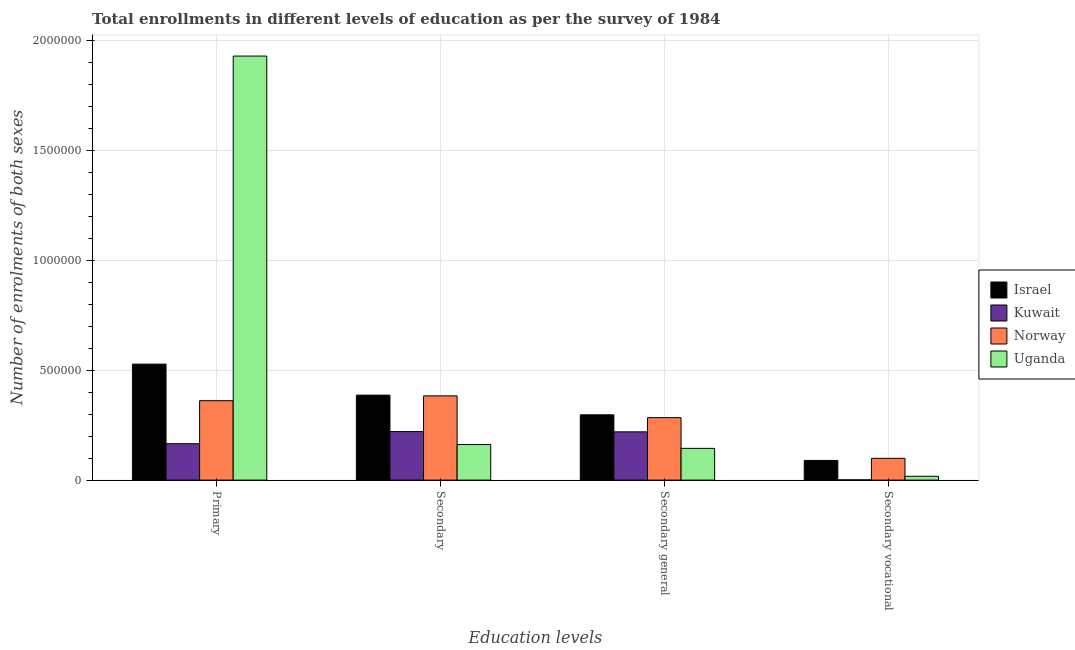How many groups of bars are there?
Provide a succinct answer. 4. Are the number of bars per tick equal to the number of legend labels?
Your answer should be compact. Yes. Are the number of bars on each tick of the X-axis equal?
Provide a succinct answer. Yes. How many bars are there on the 1st tick from the left?
Make the answer very short. 4. How many bars are there on the 1st tick from the right?
Ensure brevity in your answer.  4. What is the label of the 2nd group of bars from the left?
Provide a short and direct response. Secondary. What is the number of enrolments in secondary education in Israel?
Offer a very short reply. 3.87e+05. Across all countries, what is the maximum number of enrolments in secondary education?
Keep it short and to the point. 3.87e+05. Across all countries, what is the minimum number of enrolments in secondary general education?
Your answer should be compact. 1.45e+05. In which country was the number of enrolments in primary education maximum?
Provide a short and direct response. Uganda. In which country was the number of enrolments in primary education minimum?
Make the answer very short. Kuwait. What is the total number of enrolments in secondary general education in the graph?
Your response must be concise. 9.46e+05. What is the difference between the number of enrolments in secondary vocational education in Norway and that in Uganda?
Your response must be concise. 8.17e+04. What is the difference between the number of enrolments in secondary education in Uganda and the number of enrolments in secondary general education in Norway?
Provide a short and direct response. -1.22e+05. What is the average number of enrolments in secondary general education per country?
Your answer should be compact. 2.36e+05. What is the difference between the number of enrolments in secondary general education and number of enrolments in secondary education in Norway?
Your response must be concise. -9.91e+04. What is the ratio of the number of enrolments in secondary general education in Norway to that in Israel?
Your response must be concise. 0.96. Is the difference between the number of enrolments in secondary general education in Kuwait and Israel greater than the difference between the number of enrolments in secondary vocational education in Kuwait and Israel?
Your response must be concise. Yes. What is the difference between the highest and the second highest number of enrolments in secondary vocational education?
Offer a very short reply. 9485. What is the difference between the highest and the lowest number of enrolments in secondary vocational education?
Provide a succinct answer. 9.79e+04. In how many countries, is the number of enrolments in primary education greater than the average number of enrolments in primary education taken over all countries?
Your answer should be very brief. 1. What does the 3rd bar from the right in Secondary general represents?
Keep it short and to the point. Kuwait. How many bars are there?
Provide a succinct answer. 16. Are all the bars in the graph horizontal?
Give a very brief answer. No. What is the difference between two consecutive major ticks on the Y-axis?
Provide a succinct answer. 5.00e+05. Are the values on the major ticks of Y-axis written in scientific E-notation?
Provide a short and direct response. No. Does the graph contain any zero values?
Make the answer very short. No. Does the graph contain grids?
Ensure brevity in your answer.  Yes. Where does the legend appear in the graph?
Offer a very short reply. Center right. How many legend labels are there?
Make the answer very short. 4. What is the title of the graph?
Make the answer very short. Total enrollments in different levels of education as per the survey of 1984. Does "United Kingdom" appear as one of the legend labels in the graph?
Your response must be concise. No. What is the label or title of the X-axis?
Ensure brevity in your answer.  Education levels. What is the label or title of the Y-axis?
Provide a succinct answer. Number of enrolments of both sexes. What is the Number of enrolments of both sexes in Israel in Primary?
Your answer should be very brief. 5.28e+05. What is the Number of enrolments of both sexes of Kuwait in Primary?
Provide a succinct answer. 1.66e+05. What is the Number of enrolments of both sexes in Norway in Primary?
Your answer should be compact. 3.62e+05. What is the Number of enrolments of both sexes in Uganda in Primary?
Your answer should be compact. 1.93e+06. What is the Number of enrolments of both sexes in Israel in Secondary?
Your answer should be compact. 3.87e+05. What is the Number of enrolments of both sexes in Kuwait in Secondary?
Offer a very short reply. 2.21e+05. What is the Number of enrolments of both sexes in Norway in Secondary?
Your answer should be compact. 3.83e+05. What is the Number of enrolments of both sexes in Uganda in Secondary?
Your answer should be compact. 1.62e+05. What is the Number of enrolments of both sexes in Israel in Secondary general?
Your response must be concise. 2.97e+05. What is the Number of enrolments of both sexes of Kuwait in Secondary general?
Keep it short and to the point. 2.20e+05. What is the Number of enrolments of both sexes in Norway in Secondary general?
Offer a terse response. 2.84e+05. What is the Number of enrolments of both sexes of Uganda in Secondary general?
Keep it short and to the point. 1.45e+05. What is the Number of enrolments of both sexes of Israel in Secondary vocational?
Your response must be concise. 8.96e+04. What is the Number of enrolments of both sexes in Kuwait in Secondary vocational?
Give a very brief answer. 1223. What is the Number of enrolments of both sexes in Norway in Secondary vocational?
Make the answer very short. 9.91e+04. What is the Number of enrolments of both sexes in Uganda in Secondary vocational?
Ensure brevity in your answer.  1.75e+04. Across all Education levels, what is the maximum Number of enrolments of both sexes in Israel?
Your answer should be compact. 5.28e+05. Across all Education levels, what is the maximum Number of enrolments of both sexes in Kuwait?
Offer a very short reply. 2.21e+05. Across all Education levels, what is the maximum Number of enrolments of both sexes in Norway?
Offer a terse response. 3.83e+05. Across all Education levels, what is the maximum Number of enrolments of both sexes of Uganda?
Offer a very short reply. 1.93e+06. Across all Education levels, what is the minimum Number of enrolments of both sexes of Israel?
Make the answer very short. 8.96e+04. Across all Education levels, what is the minimum Number of enrolments of both sexes in Kuwait?
Provide a succinct answer. 1223. Across all Education levels, what is the minimum Number of enrolments of both sexes of Norway?
Your answer should be compact. 9.91e+04. Across all Education levels, what is the minimum Number of enrolments of both sexes in Uganda?
Offer a terse response. 1.75e+04. What is the total Number of enrolments of both sexes of Israel in the graph?
Offer a very short reply. 1.30e+06. What is the total Number of enrolments of both sexes in Kuwait in the graph?
Provide a short and direct response. 6.08e+05. What is the total Number of enrolments of both sexes of Norway in the graph?
Ensure brevity in your answer.  1.13e+06. What is the total Number of enrolments of both sexes of Uganda in the graph?
Keep it short and to the point. 2.25e+06. What is the difference between the Number of enrolments of both sexes in Israel in Primary and that in Secondary?
Ensure brevity in your answer.  1.41e+05. What is the difference between the Number of enrolments of both sexes of Kuwait in Primary and that in Secondary?
Make the answer very short. -5.53e+04. What is the difference between the Number of enrolments of both sexes in Norway in Primary and that in Secondary?
Ensure brevity in your answer.  -2.19e+04. What is the difference between the Number of enrolments of both sexes in Uganda in Primary and that in Secondary?
Your answer should be compact. 1.77e+06. What is the difference between the Number of enrolments of both sexes in Israel in Primary and that in Secondary general?
Keep it short and to the point. 2.31e+05. What is the difference between the Number of enrolments of both sexes of Kuwait in Primary and that in Secondary general?
Your answer should be compact. -5.41e+04. What is the difference between the Number of enrolments of both sexes in Norway in Primary and that in Secondary general?
Ensure brevity in your answer.  7.72e+04. What is the difference between the Number of enrolments of both sexes of Uganda in Primary and that in Secondary general?
Provide a short and direct response. 1.79e+06. What is the difference between the Number of enrolments of both sexes in Israel in Primary and that in Secondary vocational?
Provide a succinct answer. 4.38e+05. What is the difference between the Number of enrolments of both sexes of Kuwait in Primary and that in Secondary vocational?
Ensure brevity in your answer.  1.64e+05. What is the difference between the Number of enrolments of both sexes in Norway in Primary and that in Secondary vocational?
Your response must be concise. 2.62e+05. What is the difference between the Number of enrolments of both sexes in Uganda in Primary and that in Secondary vocational?
Keep it short and to the point. 1.91e+06. What is the difference between the Number of enrolments of both sexes of Israel in Secondary and that in Secondary general?
Your answer should be very brief. 8.96e+04. What is the difference between the Number of enrolments of both sexes in Kuwait in Secondary and that in Secondary general?
Offer a terse response. 1223. What is the difference between the Number of enrolments of both sexes in Norway in Secondary and that in Secondary general?
Your answer should be very brief. 9.91e+04. What is the difference between the Number of enrolments of both sexes in Uganda in Secondary and that in Secondary general?
Make the answer very short. 1.75e+04. What is the difference between the Number of enrolments of both sexes of Israel in Secondary and that in Secondary vocational?
Offer a terse response. 2.97e+05. What is the difference between the Number of enrolments of both sexes of Kuwait in Secondary and that in Secondary vocational?
Offer a very short reply. 2.20e+05. What is the difference between the Number of enrolments of both sexes of Norway in Secondary and that in Secondary vocational?
Your response must be concise. 2.84e+05. What is the difference between the Number of enrolments of both sexes in Uganda in Secondary and that in Secondary vocational?
Provide a succinct answer. 1.45e+05. What is the difference between the Number of enrolments of both sexes of Israel in Secondary general and that in Secondary vocational?
Offer a terse response. 2.08e+05. What is the difference between the Number of enrolments of both sexes in Kuwait in Secondary general and that in Secondary vocational?
Provide a succinct answer. 2.19e+05. What is the difference between the Number of enrolments of both sexes of Norway in Secondary general and that in Secondary vocational?
Provide a short and direct response. 1.85e+05. What is the difference between the Number of enrolments of both sexes in Uganda in Secondary general and that in Secondary vocational?
Your response must be concise. 1.27e+05. What is the difference between the Number of enrolments of both sexes in Israel in Primary and the Number of enrolments of both sexes in Kuwait in Secondary?
Keep it short and to the point. 3.07e+05. What is the difference between the Number of enrolments of both sexes of Israel in Primary and the Number of enrolments of both sexes of Norway in Secondary?
Make the answer very short. 1.44e+05. What is the difference between the Number of enrolments of both sexes of Israel in Primary and the Number of enrolments of both sexes of Uganda in Secondary?
Provide a succinct answer. 3.66e+05. What is the difference between the Number of enrolments of both sexes in Kuwait in Primary and the Number of enrolments of both sexes in Norway in Secondary?
Offer a very short reply. -2.18e+05. What is the difference between the Number of enrolments of both sexes of Kuwait in Primary and the Number of enrolments of both sexes of Uganda in Secondary?
Your answer should be compact. 3691. What is the difference between the Number of enrolments of both sexes in Norway in Primary and the Number of enrolments of both sexes in Uganda in Secondary?
Your answer should be very brief. 2.00e+05. What is the difference between the Number of enrolments of both sexes in Israel in Primary and the Number of enrolments of both sexes in Kuwait in Secondary general?
Make the answer very short. 3.08e+05. What is the difference between the Number of enrolments of both sexes of Israel in Primary and the Number of enrolments of both sexes of Norway in Secondary general?
Your response must be concise. 2.44e+05. What is the difference between the Number of enrolments of both sexes in Israel in Primary and the Number of enrolments of both sexes in Uganda in Secondary general?
Your response must be concise. 3.83e+05. What is the difference between the Number of enrolments of both sexes in Kuwait in Primary and the Number of enrolments of both sexes in Norway in Secondary general?
Give a very brief answer. -1.19e+05. What is the difference between the Number of enrolments of both sexes in Kuwait in Primary and the Number of enrolments of both sexes in Uganda in Secondary general?
Offer a terse response. 2.12e+04. What is the difference between the Number of enrolments of both sexes in Norway in Primary and the Number of enrolments of both sexes in Uganda in Secondary general?
Make the answer very short. 2.17e+05. What is the difference between the Number of enrolments of both sexes in Israel in Primary and the Number of enrolments of both sexes in Kuwait in Secondary vocational?
Your answer should be very brief. 5.27e+05. What is the difference between the Number of enrolments of both sexes in Israel in Primary and the Number of enrolments of both sexes in Norway in Secondary vocational?
Keep it short and to the point. 4.29e+05. What is the difference between the Number of enrolments of both sexes in Israel in Primary and the Number of enrolments of both sexes in Uganda in Secondary vocational?
Your answer should be compact. 5.10e+05. What is the difference between the Number of enrolments of both sexes of Kuwait in Primary and the Number of enrolments of both sexes of Norway in Secondary vocational?
Your answer should be very brief. 6.66e+04. What is the difference between the Number of enrolments of both sexes in Kuwait in Primary and the Number of enrolments of both sexes in Uganda in Secondary vocational?
Offer a terse response. 1.48e+05. What is the difference between the Number of enrolments of both sexes in Norway in Primary and the Number of enrolments of both sexes in Uganda in Secondary vocational?
Offer a very short reply. 3.44e+05. What is the difference between the Number of enrolments of both sexes of Israel in Secondary and the Number of enrolments of both sexes of Kuwait in Secondary general?
Keep it short and to the point. 1.67e+05. What is the difference between the Number of enrolments of both sexes in Israel in Secondary and the Number of enrolments of both sexes in Norway in Secondary general?
Offer a very short reply. 1.03e+05. What is the difference between the Number of enrolments of both sexes of Israel in Secondary and the Number of enrolments of both sexes of Uganda in Secondary general?
Your answer should be compact. 2.42e+05. What is the difference between the Number of enrolments of both sexes of Kuwait in Secondary and the Number of enrolments of both sexes of Norway in Secondary general?
Give a very brief answer. -6.34e+04. What is the difference between the Number of enrolments of both sexes in Kuwait in Secondary and the Number of enrolments of both sexes in Uganda in Secondary general?
Offer a terse response. 7.65e+04. What is the difference between the Number of enrolments of both sexes of Norway in Secondary and the Number of enrolments of both sexes of Uganda in Secondary general?
Provide a succinct answer. 2.39e+05. What is the difference between the Number of enrolments of both sexes in Israel in Secondary and the Number of enrolments of both sexes in Kuwait in Secondary vocational?
Offer a very short reply. 3.86e+05. What is the difference between the Number of enrolments of both sexes in Israel in Secondary and the Number of enrolments of both sexes in Norway in Secondary vocational?
Offer a very short reply. 2.88e+05. What is the difference between the Number of enrolments of both sexes of Israel in Secondary and the Number of enrolments of both sexes of Uganda in Secondary vocational?
Keep it short and to the point. 3.69e+05. What is the difference between the Number of enrolments of both sexes of Kuwait in Secondary and the Number of enrolments of both sexes of Norway in Secondary vocational?
Provide a short and direct response. 1.22e+05. What is the difference between the Number of enrolments of both sexes in Kuwait in Secondary and the Number of enrolments of both sexes in Uganda in Secondary vocational?
Your answer should be compact. 2.04e+05. What is the difference between the Number of enrolments of both sexes in Norway in Secondary and the Number of enrolments of both sexes in Uganda in Secondary vocational?
Provide a succinct answer. 3.66e+05. What is the difference between the Number of enrolments of both sexes in Israel in Secondary general and the Number of enrolments of both sexes in Kuwait in Secondary vocational?
Offer a very short reply. 2.96e+05. What is the difference between the Number of enrolments of both sexes in Israel in Secondary general and the Number of enrolments of both sexes in Norway in Secondary vocational?
Provide a succinct answer. 1.98e+05. What is the difference between the Number of enrolments of both sexes of Israel in Secondary general and the Number of enrolments of both sexes of Uganda in Secondary vocational?
Offer a terse response. 2.80e+05. What is the difference between the Number of enrolments of both sexes in Kuwait in Secondary general and the Number of enrolments of both sexes in Norway in Secondary vocational?
Keep it short and to the point. 1.21e+05. What is the difference between the Number of enrolments of both sexes of Kuwait in Secondary general and the Number of enrolments of both sexes of Uganda in Secondary vocational?
Your answer should be very brief. 2.02e+05. What is the difference between the Number of enrolments of both sexes of Norway in Secondary general and the Number of enrolments of both sexes of Uganda in Secondary vocational?
Provide a succinct answer. 2.67e+05. What is the average Number of enrolments of both sexes of Israel per Education levels?
Offer a very short reply. 3.25e+05. What is the average Number of enrolments of both sexes in Kuwait per Education levels?
Offer a terse response. 1.52e+05. What is the average Number of enrolments of both sexes in Norway per Education levels?
Your answer should be compact. 2.82e+05. What is the average Number of enrolments of both sexes of Uganda per Education levels?
Make the answer very short. 5.64e+05. What is the difference between the Number of enrolments of both sexes of Israel and Number of enrolments of both sexes of Kuwait in Primary?
Offer a terse response. 3.62e+05. What is the difference between the Number of enrolments of both sexes in Israel and Number of enrolments of both sexes in Norway in Primary?
Offer a terse response. 1.66e+05. What is the difference between the Number of enrolments of both sexes of Israel and Number of enrolments of both sexes of Uganda in Primary?
Your answer should be compact. -1.40e+06. What is the difference between the Number of enrolments of both sexes in Kuwait and Number of enrolments of both sexes in Norway in Primary?
Offer a very short reply. -1.96e+05. What is the difference between the Number of enrolments of both sexes in Kuwait and Number of enrolments of both sexes in Uganda in Primary?
Keep it short and to the point. -1.76e+06. What is the difference between the Number of enrolments of both sexes of Norway and Number of enrolments of both sexes of Uganda in Primary?
Provide a succinct answer. -1.57e+06. What is the difference between the Number of enrolments of both sexes in Israel and Number of enrolments of both sexes in Kuwait in Secondary?
Give a very brief answer. 1.66e+05. What is the difference between the Number of enrolments of both sexes in Israel and Number of enrolments of both sexes in Norway in Secondary?
Your answer should be very brief. 3393. What is the difference between the Number of enrolments of both sexes of Israel and Number of enrolments of both sexes of Uganda in Secondary?
Your answer should be very brief. 2.25e+05. What is the difference between the Number of enrolments of both sexes in Kuwait and Number of enrolments of both sexes in Norway in Secondary?
Make the answer very short. -1.63e+05. What is the difference between the Number of enrolments of both sexes of Kuwait and Number of enrolments of both sexes of Uganda in Secondary?
Give a very brief answer. 5.90e+04. What is the difference between the Number of enrolments of both sexes of Norway and Number of enrolments of both sexes of Uganda in Secondary?
Give a very brief answer. 2.21e+05. What is the difference between the Number of enrolments of both sexes of Israel and Number of enrolments of both sexes of Kuwait in Secondary general?
Provide a short and direct response. 7.75e+04. What is the difference between the Number of enrolments of both sexes in Israel and Number of enrolments of both sexes in Norway in Secondary general?
Offer a terse response. 1.29e+04. What is the difference between the Number of enrolments of both sexes of Israel and Number of enrolments of both sexes of Uganda in Secondary general?
Give a very brief answer. 1.53e+05. What is the difference between the Number of enrolments of both sexes of Kuwait and Number of enrolments of both sexes of Norway in Secondary general?
Give a very brief answer. -6.46e+04. What is the difference between the Number of enrolments of both sexes in Kuwait and Number of enrolments of both sexes in Uganda in Secondary general?
Offer a very short reply. 7.52e+04. What is the difference between the Number of enrolments of both sexes in Norway and Number of enrolments of both sexes in Uganda in Secondary general?
Provide a succinct answer. 1.40e+05. What is the difference between the Number of enrolments of both sexes in Israel and Number of enrolments of both sexes in Kuwait in Secondary vocational?
Ensure brevity in your answer.  8.84e+04. What is the difference between the Number of enrolments of both sexes in Israel and Number of enrolments of both sexes in Norway in Secondary vocational?
Your answer should be very brief. -9485. What is the difference between the Number of enrolments of both sexes in Israel and Number of enrolments of both sexes in Uganda in Secondary vocational?
Make the answer very short. 7.22e+04. What is the difference between the Number of enrolments of both sexes in Kuwait and Number of enrolments of both sexes in Norway in Secondary vocational?
Give a very brief answer. -9.79e+04. What is the difference between the Number of enrolments of both sexes in Kuwait and Number of enrolments of both sexes in Uganda in Secondary vocational?
Your answer should be very brief. -1.63e+04. What is the difference between the Number of enrolments of both sexes of Norway and Number of enrolments of both sexes of Uganda in Secondary vocational?
Keep it short and to the point. 8.17e+04. What is the ratio of the Number of enrolments of both sexes in Israel in Primary to that in Secondary?
Offer a terse response. 1.36. What is the ratio of the Number of enrolments of both sexes in Kuwait in Primary to that in Secondary?
Give a very brief answer. 0.75. What is the ratio of the Number of enrolments of both sexes of Norway in Primary to that in Secondary?
Give a very brief answer. 0.94. What is the ratio of the Number of enrolments of both sexes in Uganda in Primary to that in Secondary?
Offer a terse response. 11.92. What is the ratio of the Number of enrolments of both sexes in Israel in Primary to that in Secondary general?
Your answer should be very brief. 1.78. What is the ratio of the Number of enrolments of both sexes in Kuwait in Primary to that in Secondary general?
Keep it short and to the point. 0.75. What is the ratio of the Number of enrolments of both sexes in Norway in Primary to that in Secondary general?
Offer a very short reply. 1.27. What is the ratio of the Number of enrolments of both sexes of Uganda in Primary to that in Secondary general?
Give a very brief answer. 13.36. What is the ratio of the Number of enrolments of both sexes in Israel in Primary to that in Secondary vocational?
Your answer should be compact. 5.89. What is the ratio of the Number of enrolments of both sexes of Kuwait in Primary to that in Secondary vocational?
Your response must be concise. 135.48. What is the ratio of the Number of enrolments of both sexes in Norway in Primary to that in Secondary vocational?
Make the answer very short. 3.65. What is the ratio of the Number of enrolments of both sexes in Uganda in Primary to that in Secondary vocational?
Your answer should be compact. 110.44. What is the ratio of the Number of enrolments of both sexes of Israel in Secondary to that in Secondary general?
Your answer should be compact. 1.3. What is the ratio of the Number of enrolments of both sexes in Kuwait in Secondary to that in Secondary general?
Offer a very short reply. 1.01. What is the ratio of the Number of enrolments of both sexes of Norway in Secondary to that in Secondary general?
Your response must be concise. 1.35. What is the ratio of the Number of enrolments of both sexes of Uganda in Secondary to that in Secondary general?
Ensure brevity in your answer.  1.12. What is the ratio of the Number of enrolments of both sexes in Israel in Secondary to that in Secondary vocational?
Give a very brief answer. 4.32. What is the ratio of the Number of enrolments of both sexes of Kuwait in Secondary to that in Secondary vocational?
Your answer should be very brief. 180.69. What is the ratio of the Number of enrolments of both sexes of Norway in Secondary to that in Secondary vocational?
Offer a terse response. 3.87. What is the ratio of the Number of enrolments of both sexes of Uganda in Secondary to that in Secondary vocational?
Provide a short and direct response. 9.27. What is the ratio of the Number of enrolments of both sexes in Israel in Secondary general to that in Secondary vocational?
Ensure brevity in your answer.  3.32. What is the ratio of the Number of enrolments of both sexes of Kuwait in Secondary general to that in Secondary vocational?
Provide a short and direct response. 179.69. What is the ratio of the Number of enrolments of both sexes of Norway in Secondary general to that in Secondary vocational?
Give a very brief answer. 2.87. What is the ratio of the Number of enrolments of both sexes of Uganda in Secondary general to that in Secondary vocational?
Provide a short and direct response. 8.27. What is the difference between the highest and the second highest Number of enrolments of both sexes in Israel?
Your response must be concise. 1.41e+05. What is the difference between the highest and the second highest Number of enrolments of both sexes of Kuwait?
Offer a terse response. 1223. What is the difference between the highest and the second highest Number of enrolments of both sexes of Norway?
Ensure brevity in your answer.  2.19e+04. What is the difference between the highest and the second highest Number of enrolments of both sexes of Uganda?
Provide a short and direct response. 1.77e+06. What is the difference between the highest and the lowest Number of enrolments of both sexes of Israel?
Make the answer very short. 4.38e+05. What is the difference between the highest and the lowest Number of enrolments of both sexes in Kuwait?
Provide a short and direct response. 2.20e+05. What is the difference between the highest and the lowest Number of enrolments of both sexes in Norway?
Your response must be concise. 2.84e+05. What is the difference between the highest and the lowest Number of enrolments of both sexes of Uganda?
Your answer should be compact. 1.91e+06. 